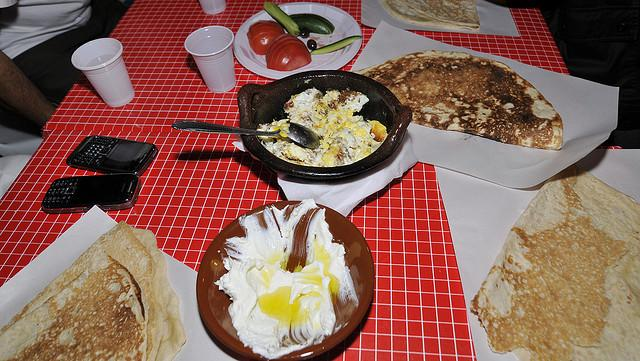This meal is likely for how many people?

Choices:
A) two
B) five
C) thirty
D) one two 